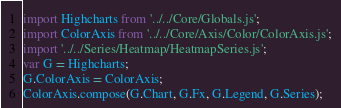Convert code to text. <code><loc_0><loc_0><loc_500><loc_500><_JavaScript_>import Highcharts from '../../Core/Globals.js';
import ColorAxis from '../../Core/Axis/Color/ColorAxis.js';
import '../../Series/Heatmap/HeatmapSeries.js';
var G = Highcharts;
G.ColorAxis = ColorAxis;
ColorAxis.compose(G.Chart, G.Fx, G.Legend, G.Series);
</code> 